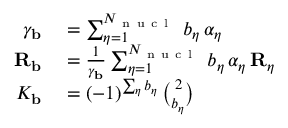Convert formula to latex. <formula><loc_0><loc_0><loc_500><loc_500>\begin{array} { r l } { \gamma _ { b } } & = \sum _ { \eta = 1 } ^ { N _ { n u c l } } \, b _ { \eta } \, \alpha _ { \eta } } \\ { { R _ { b } } } & = \frac { 1 } { \gamma _ { b } } \sum _ { \eta = 1 } ^ { N _ { n u c l } } \, b _ { \eta } \, \alpha _ { \eta } \, { R _ { \eta } } } \\ { K _ { b } } & = ( - 1 ) ^ { \sum _ { \eta } b _ { \eta } } \, { \binom { 2 } { b _ { \eta } } } } \end{array}</formula> 